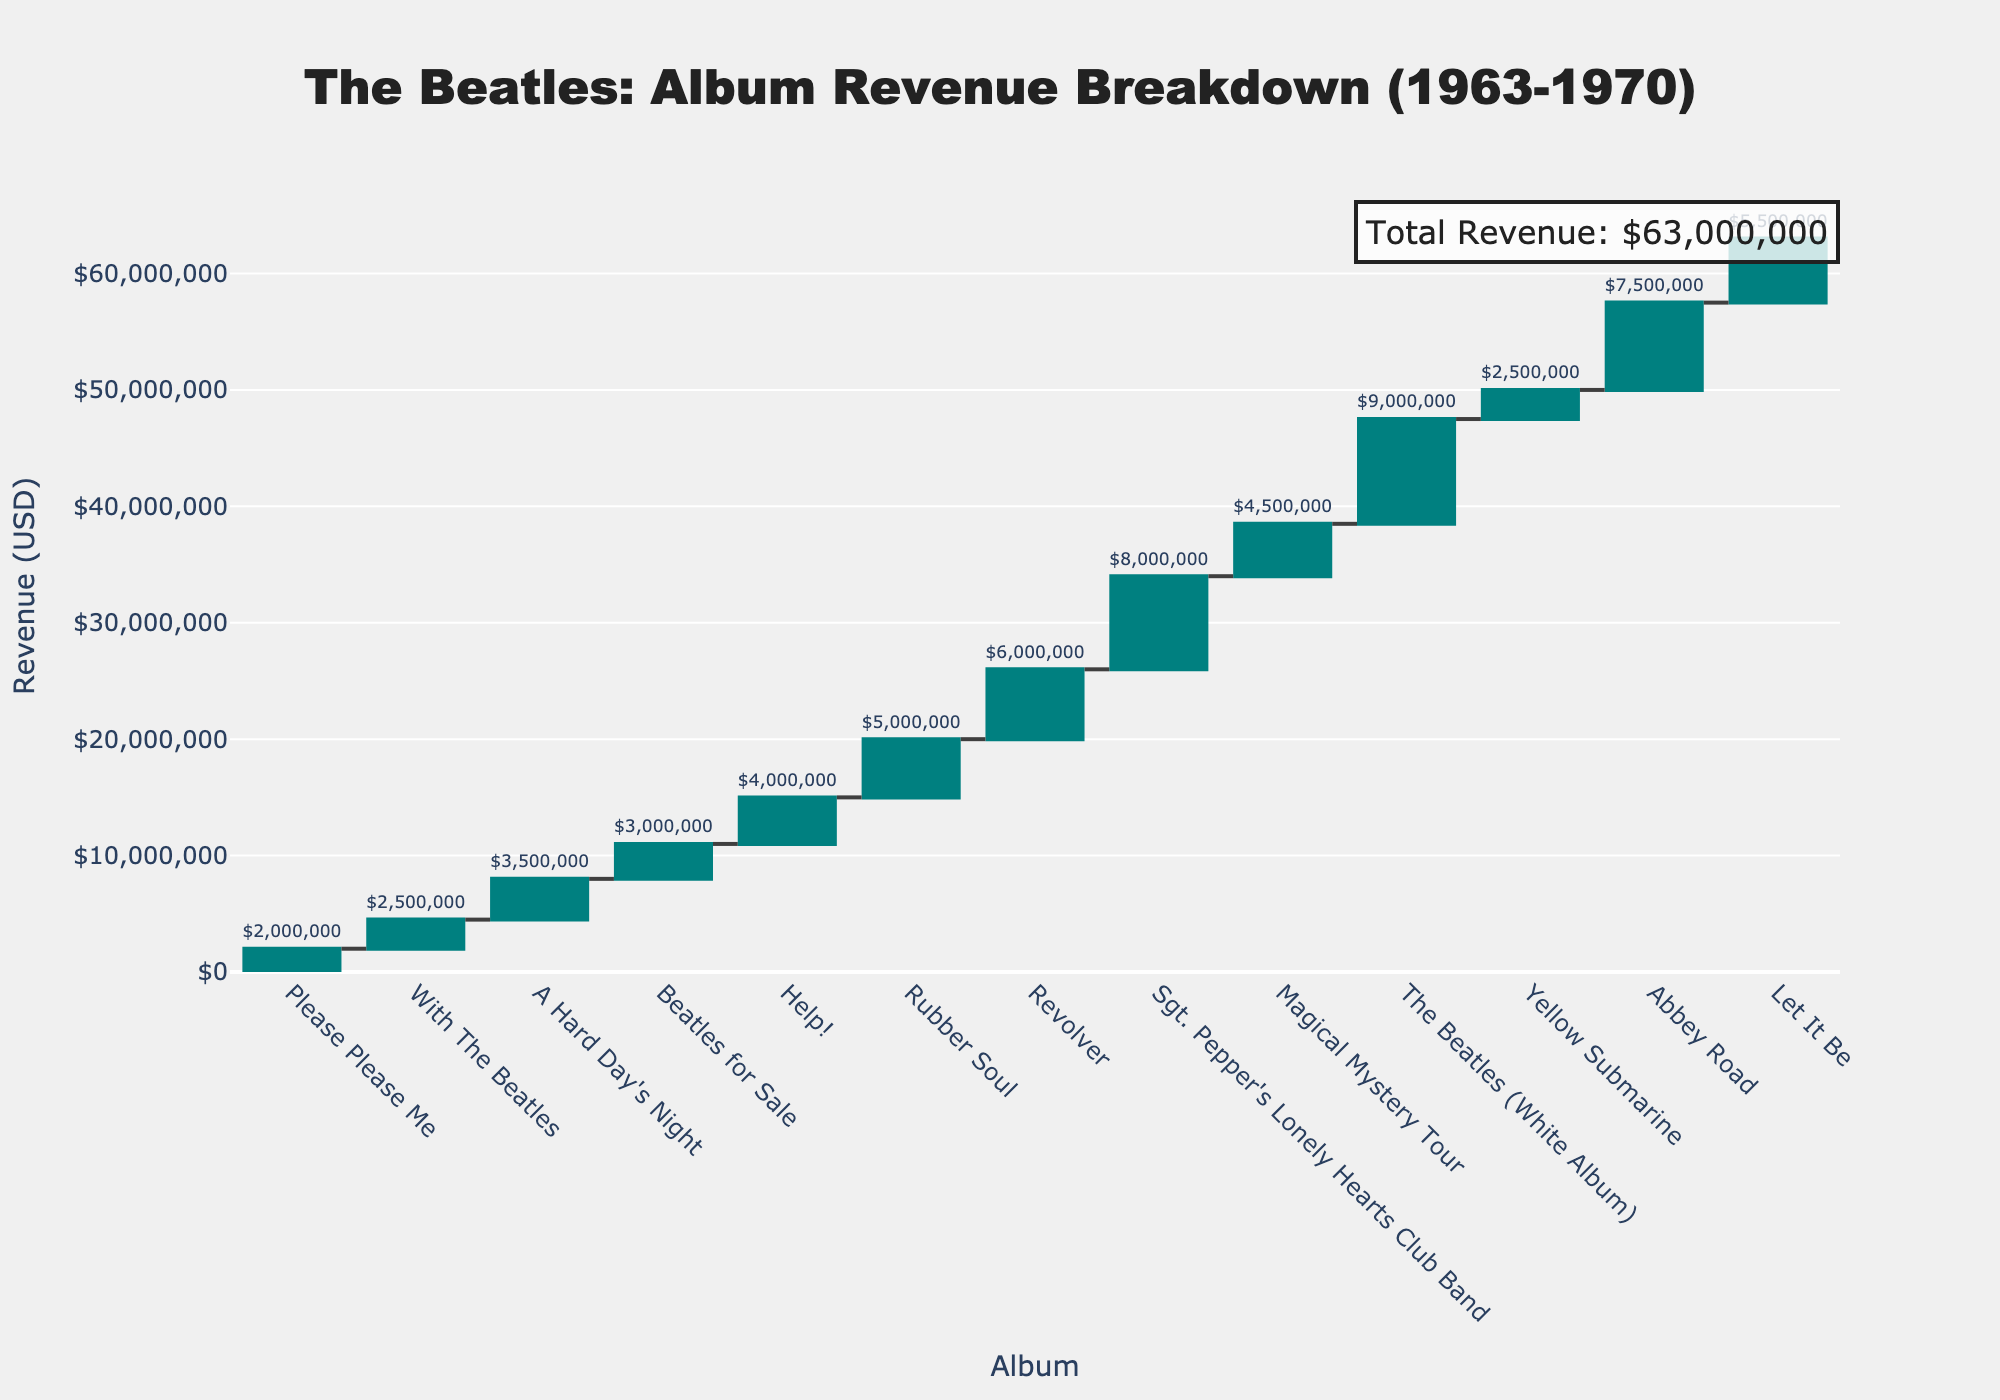Which album generated the highest revenue? From the figure, the album that has the tallest bar in the waterfall chart represents the album with the highest revenue. Observe that "The Beatles (White Album)" has the highest bar.
Answer: The Beatles (White Album) What is the total revenue from the Beatles' albums released between 1965 and 1967? Identify the albums released in that period: "Help!" (1965), "Rubber Soul" (1965), "Revolver" (1966), "Sgt. Pepper's Lonely Hearts Club Band" (1967), and sum their revenues: 4,000,000 + 5,000,000 + 6,000,000 + 8,000,000 = 23,000,000
Answer: 23,000,000 Which album had the least revenue, and what was that amount? Find the bar with the smallest height on the chart; "Please Please Me" appears to be the shortest bar, indicating it has the least revenue. Checking the label confirms it generated $2,000,000.
Answer: Please Please Me, $2,000,000 How much more revenue did "Abbey Road" generate compared to "Beatles for Sale"? Look at the bars representing "Abbey Road" and "Beatles for Sale". "Abbey Road" generated $7,500,000 and "Beatles for Sale" generated $3,000,000. The difference is 7,500,000 - 3,000,000 = 4,500,000
Answer: $4,500,000 What is the cumulative revenue up to "Revolver"? Sum the revenues of all albums up to and including "Revolver": 2,000,000 (Please Please Me) + 2,500,000 (With The Beatles) + 3,500,000 (A Hard Day's Night) + 3,000,000 (Beatles for Sale) + 4,000,000 (Help!) + 5,000,000 (Rubber Soul) + 6,000,000 (Revolver) = 26,000,000
Answer: $26,000,000 Which period shows the highest revenue increase between consecutive albums? Compare the differences in revenue between each consecutive pair of albums. The largest revenue jump is from "Revolver" ($6,000,000) to "Sgt. Pepper's Lonely Hearts Club Band" ($8,000,000), an increase of 2,000,000.
Answer: Between Revolver and Sgt. Pepper's Lonely Hearts Club Band What is the average revenue generated per album? Calculate the average by summing the revenues of all albums and dividing by the number of albums: (2,000,000 + 2,500,000 + 3,500,000 + 3,000,000 + 4,000,000 + 5,000,000 + 6,000,000 + 8,000,000 + 4,500,000 + 9,000,000 + 2,500,000 + 7,500,000 + 5,500,000) / 13 = 48,000,000 / 13 ≈ 4,846,153
Answer: $4,846,153 Which album released after "Rubber Soul" had revenue closest to "With The Beatles"? "With The Beatles" generated $2,500,000. Among albums released after "Rubber Soul", "Yellow Submarine" also generated $2,500,000, matching "With The Beatles" revenue closely.
Answer: Yellow Submarine How does the revenue of "Let It Be" compare to the summed revenue of the first three albums? "Let It Be" generated $5,500,000. The first three albums' summed revenue is: 2,000,000 (Please Please Me) + 2,500,000 (With The Beatles) + 3,500,000 (A Hard Day's Night) = 8,000,000. Thus, "Let It Be" generated less revenue by 8,000,000 - 5,500,000 = 2,500,000.
Answer: $2,500,000 less 